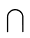Convert formula to latex. <formula><loc_0><loc_0><loc_500><loc_500>\bigcap</formula> 